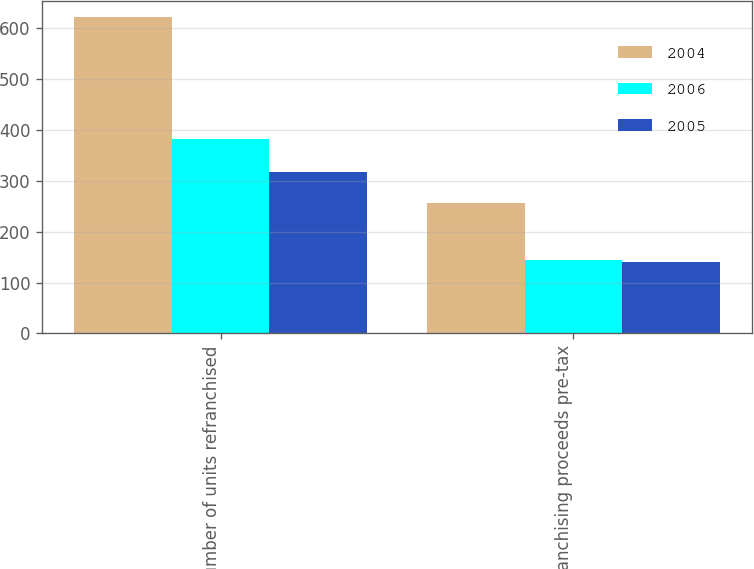Convert chart. <chart><loc_0><loc_0><loc_500><loc_500><stacked_bar_chart><ecel><fcel>Number of units refranchised<fcel>Refranchising proceeds pre-tax<nl><fcel>2004<fcel>622<fcel>257<nl><fcel>2006<fcel>382<fcel>145<nl><fcel>2005<fcel>317<fcel>140<nl></chart> 